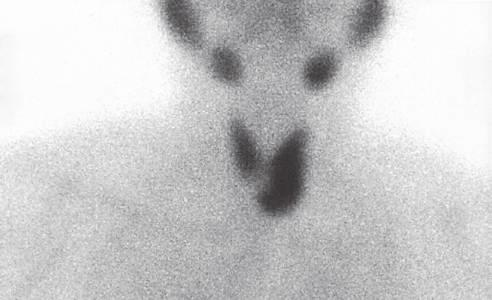s this benign tumor proved to be a parathyroid adenoma?
Answer the question using a single word or phrase. No 